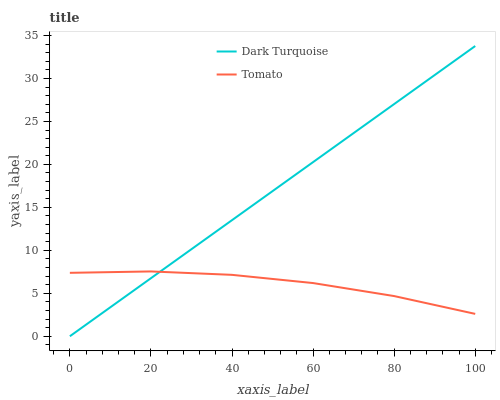Does Tomato have the minimum area under the curve?
Answer yes or no. Yes. Does Dark Turquoise have the maximum area under the curve?
Answer yes or no. Yes. Does Dark Turquoise have the minimum area under the curve?
Answer yes or no. No. Is Dark Turquoise the smoothest?
Answer yes or no. Yes. Is Tomato the roughest?
Answer yes or no. Yes. Is Dark Turquoise the roughest?
Answer yes or no. No. Does Dark Turquoise have the highest value?
Answer yes or no. Yes. Does Dark Turquoise intersect Tomato?
Answer yes or no. Yes. Is Dark Turquoise less than Tomato?
Answer yes or no. No. Is Dark Turquoise greater than Tomato?
Answer yes or no. No. 